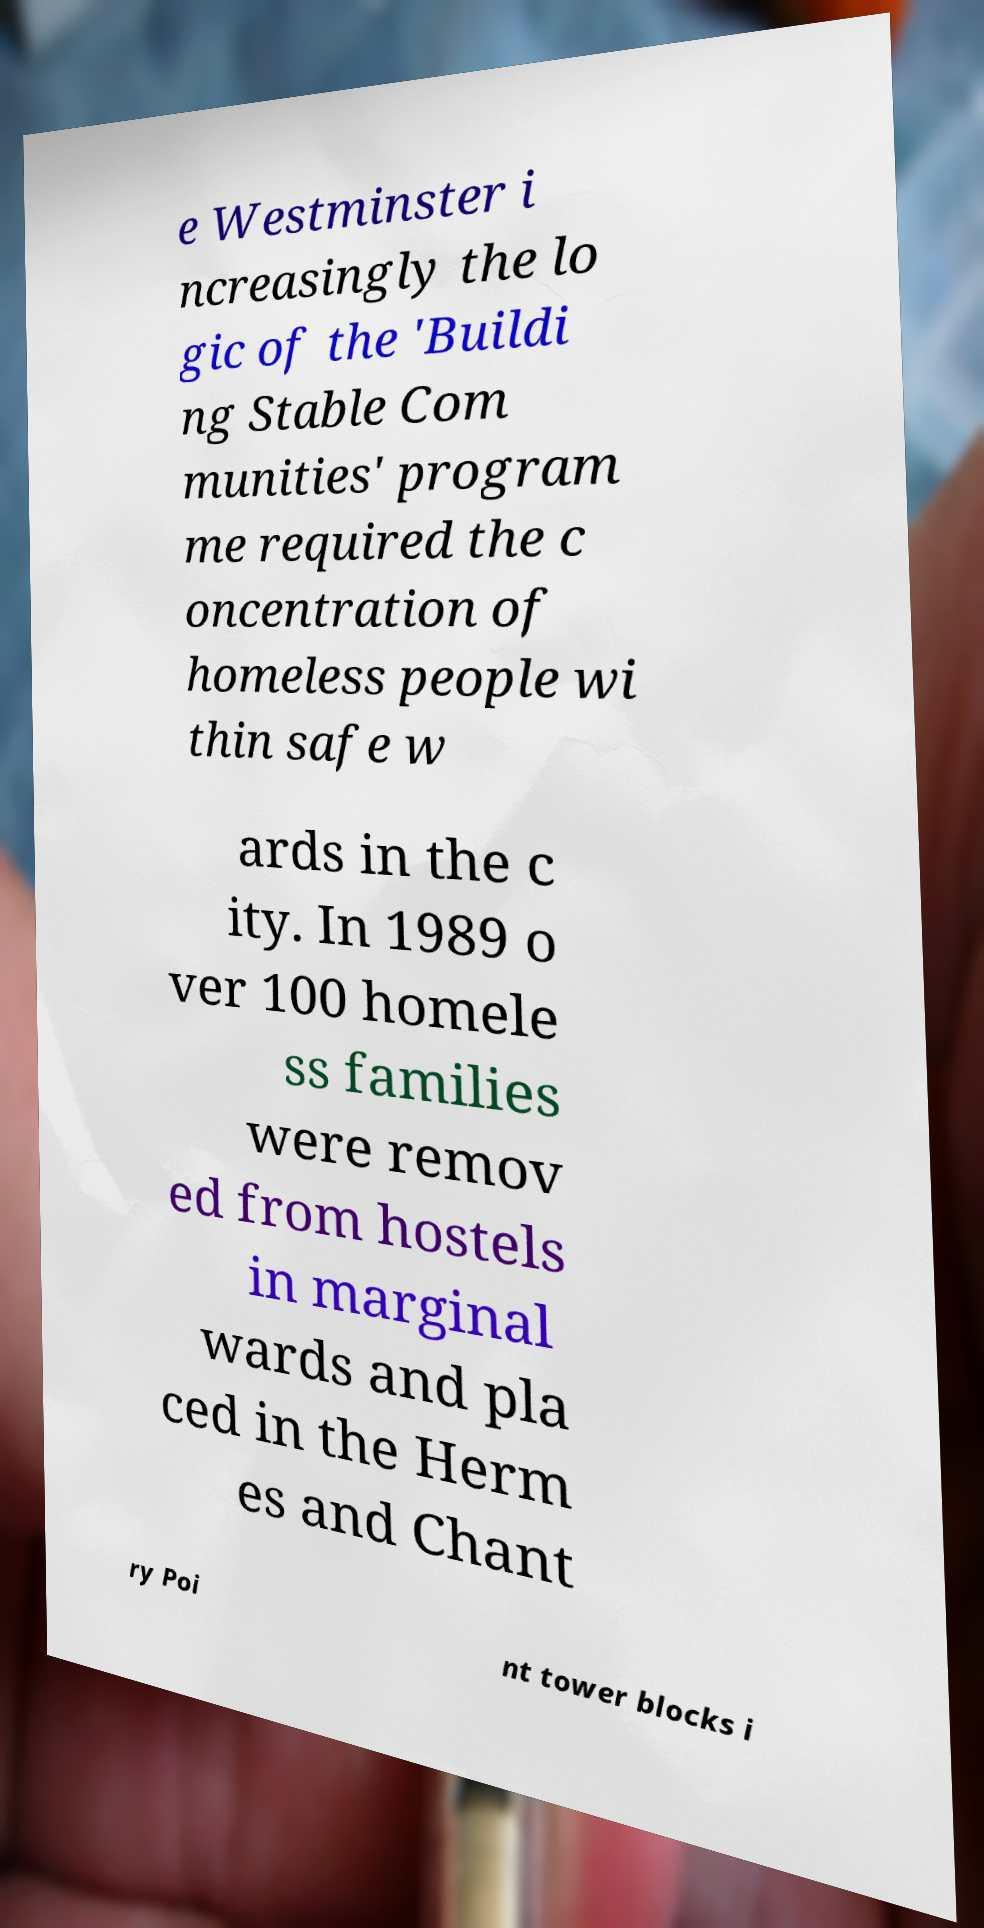Could you extract and type out the text from this image? e Westminster i ncreasingly the lo gic of the 'Buildi ng Stable Com munities' program me required the c oncentration of homeless people wi thin safe w ards in the c ity. In 1989 o ver 100 homele ss families were remov ed from hostels in marginal wards and pla ced in the Herm es and Chant ry Poi nt tower blocks i 